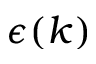Convert formula to latex. <formula><loc_0><loc_0><loc_500><loc_500>\epsilon ( k )</formula> 